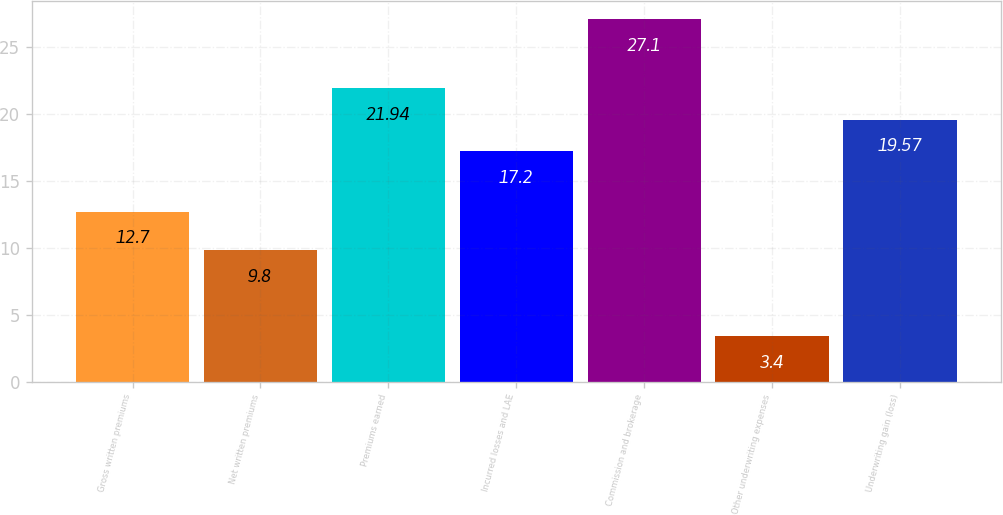Convert chart. <chart><loc_0><loc_0><loc_500><loc_500><bar_chart><fcel>Gross written premiums<fcel>Net written premiums<fcel>Premiums earned<fcel>Incurred losses and LAE<fcel>Commission and brokerage<fcel>Other underwriting expenses<fcel>Underwriting gain (loss)<nl><fcel>12.7<fcel>9.8<fcel>21.94<fcel>17.2<fcel>27.1<fcel>3.4<fcel>19.57<nl></chart> 